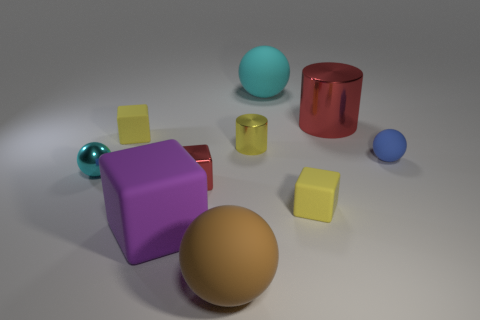What number of small matte things are behind the small red object?
Offer a very short reply. 2. What number of purple things are either rubber objects or large metallic cylinders?
Offer a terse response. 1. What is the material of the cyan ball that is the same size as the yellow metal cylinder?
Offer a terse response. Metal. There is a object that is both behind the small blue matte ball and on the left side of the small cylinder; what shape is it?
Ensure brevity in your answer.  Cube. There is a sphere that is the same size as the blue object; what is its color?
Your answer should be very brief. Cyan. There is a yellow rubber cube behind the blue matte sphere; is its size the same as the red shiny object that is to the right of the small red object?
Offer a terse response. No. What is the size of the yellow matte thing that is to the right of the ball that is behind the tiny yellow rubber object that is on the left side of the big cyan ball?
Provide a short and direct response. Small. There is a tiny yellow shiny thing that is behind the yellow rubber thing right of the brown rubber sphere; what shape is it?
Ensure brevity in your answer.  Cylinder. There is a tiny cube that is in front of the small red thing; is it the same color as the tiny metal cylinder?
Ensure brevity in your answer.  Yes. What color is the object that is behind the cyan shiny sphere and left of the tiny red metal block?
Offer a terse response. Yellow. 